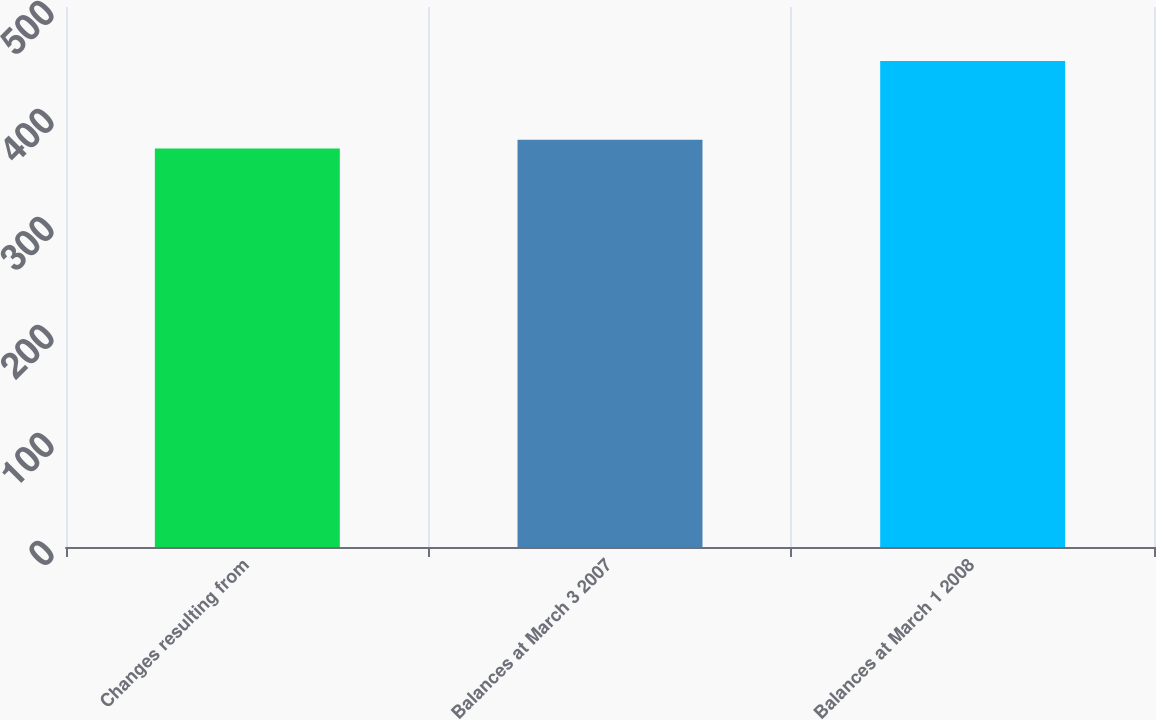Convert chart. <chart><loc_0><loc_0><loc_500><loc_500><bar_chart><fcel>Changes resulting from<fcel>Balances at March 3 2007<fcel>Balances at March 1 2008<nl><fcel>369<fcel>377.1<fcel>450<nl></chart> 